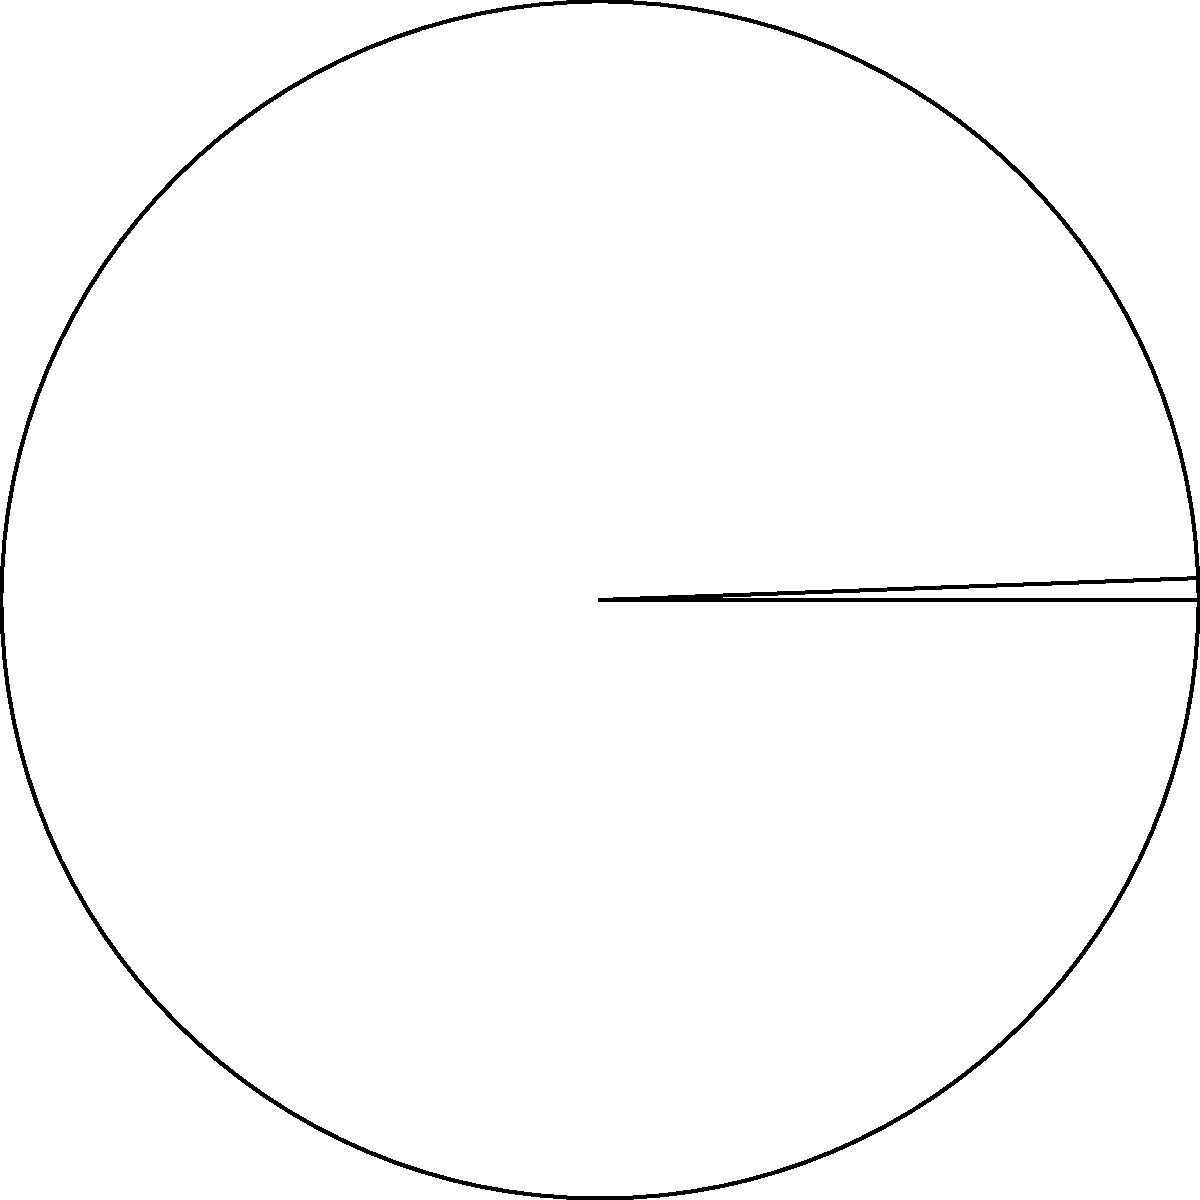In the circular sector shown above, the radius $r$ is 6 cm and the central angle $\theta$ is $\frac{2\pi}{3}$ radians. Calculate the area of the sector to the nearest square centimeter. To find the area of a circular sector, we use the formula:

$$A = \frac{1}{2}r^2\theta$$

Where:
$A$ is the area of the sector
$r$ is the radius
$\theta$ is the central angle in radians

Step 1: Substitute the given values into the formula.
$$A = \frac{1}{2} \cdot 6^2 \cdot \frac{2\pi}{3}$$

Step 2: Simplify the expression.
$$A = \frac{1}{2} \cdot 36 \cdot \frac{2\pi}{3}$$
$$A = 18 \cdot \frac{2\pi}{3}$$
$$A = 12\pi$$

Step 3: Calculate the result.
$$A \approx 37.70 \text{ cm}^2$$

Step 4: Round to the nearest square centimeter.
$$A \approx 38 \text{ cm}^2$$
Answer: $38 \text{ cm}^2$ 